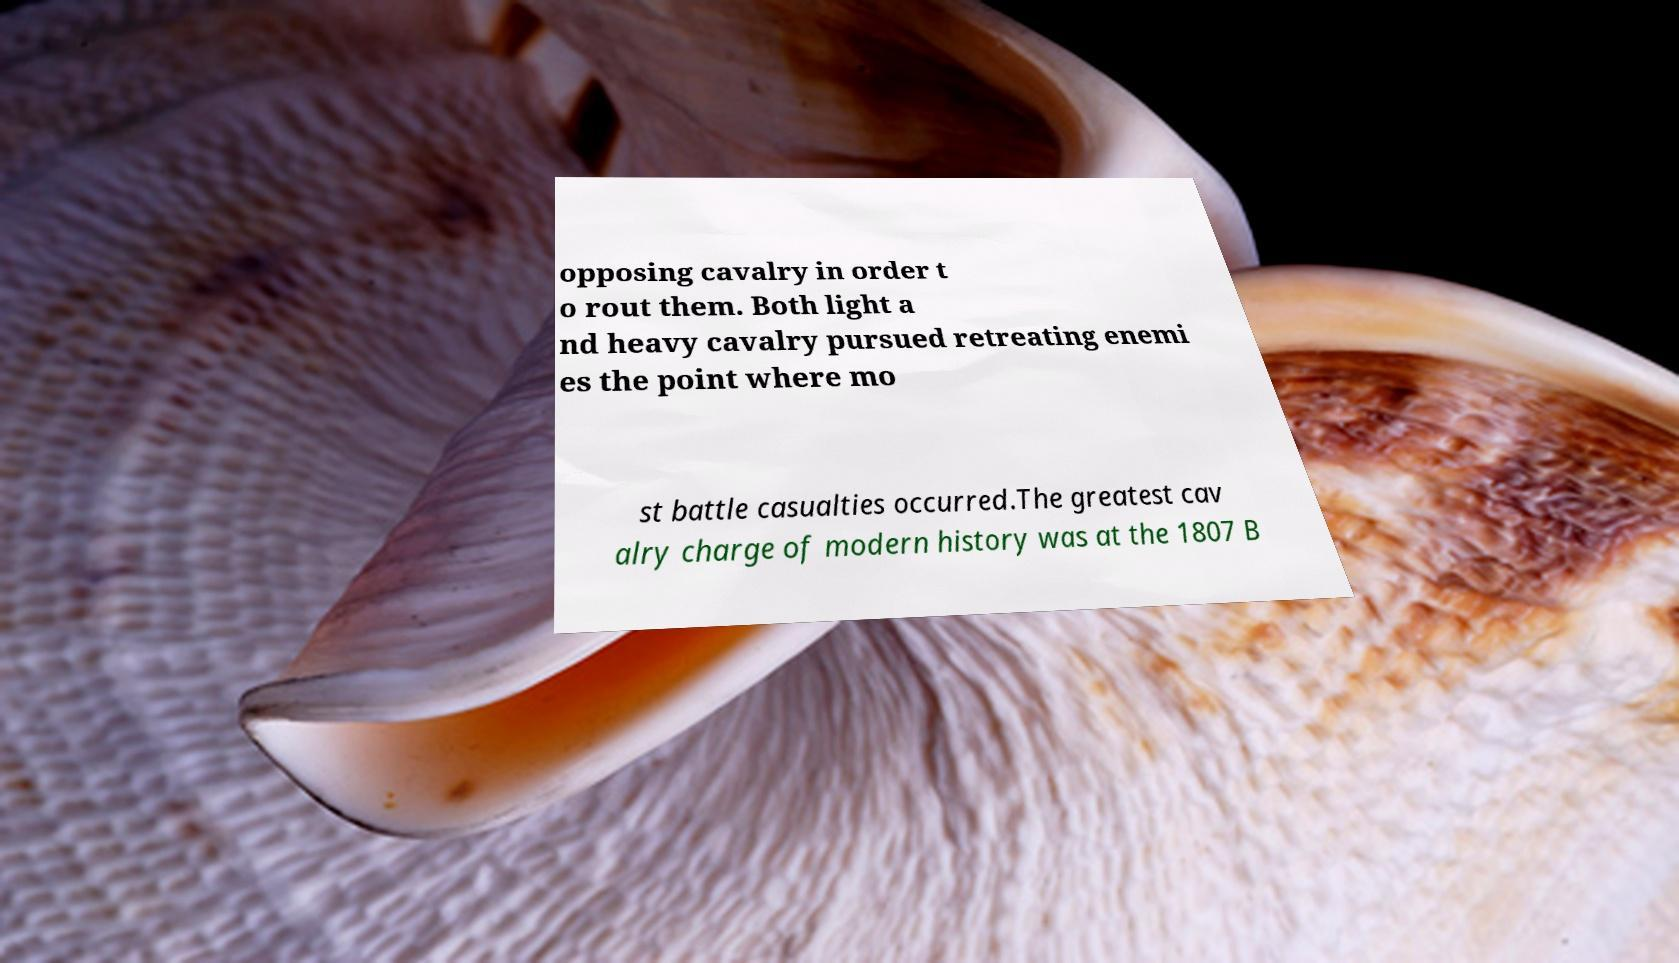Please identify and transcribe the text found in this image. opposing cavalry in order t o rout them. Both light a nd heavy cavalry pursued retreating enemi es the point where mo st battle casualties occurred.The greatest cav alry charge of modern history was at the 1807 B 